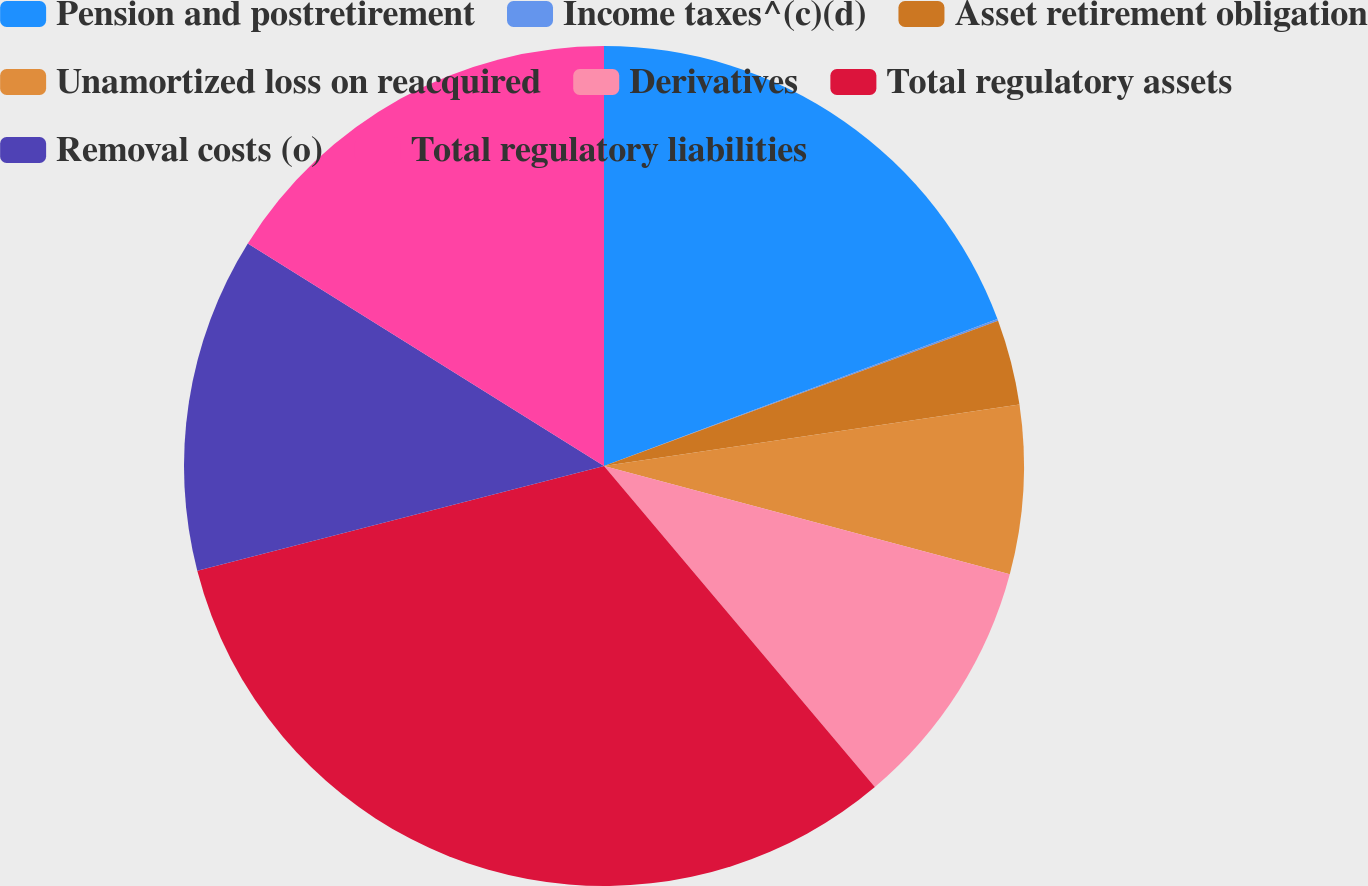Convert chart. <chart><loc_0><loc_0><loc_500><loc_500><pie_chart><fcel>Pension and postretirement<fcel>Income taxes^(c)(d)<fcel>Asset retirement obligation<fcel>Unamortized loss on reacquired<fcel>Derivatives<fcel>Total regulatory assets<fcel>Removal costs (o)<fcel>Total regulatory liabilities<nl><fcel>19.31%<fcel>0.07%<fcel>3.28%<fcel>6.49%<fcel>9.69%<fcel>32.14%<fcel>12.9%<fcel>16.11%<nl></chart> 